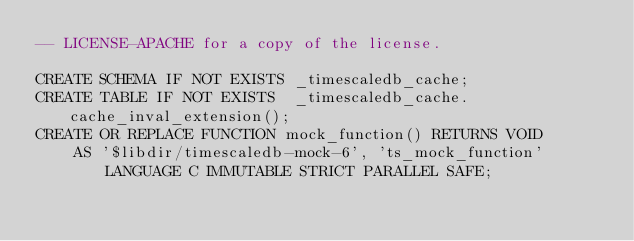Convert code to text. <code><loc_0><loc_0><loc_500><loc_500><_SQL_>-- LICENSE-APACHE for a copy of the license.

CREATE SCHEMA IF NOT EXISTS _timescaledb_cache;
CREATE TABLE IF NOT EXISTS  _timescaledb_cache.cache_inval_extension();
CREATE OR REPLACE FUNCTION mock_function() RETURNS VOID
    AS '$libdir/timescaledb-mock-6', 'ts_mock_function' LANGUAGE C IMMUTABLE STRICT PARALLEL SAFE;
</code> 